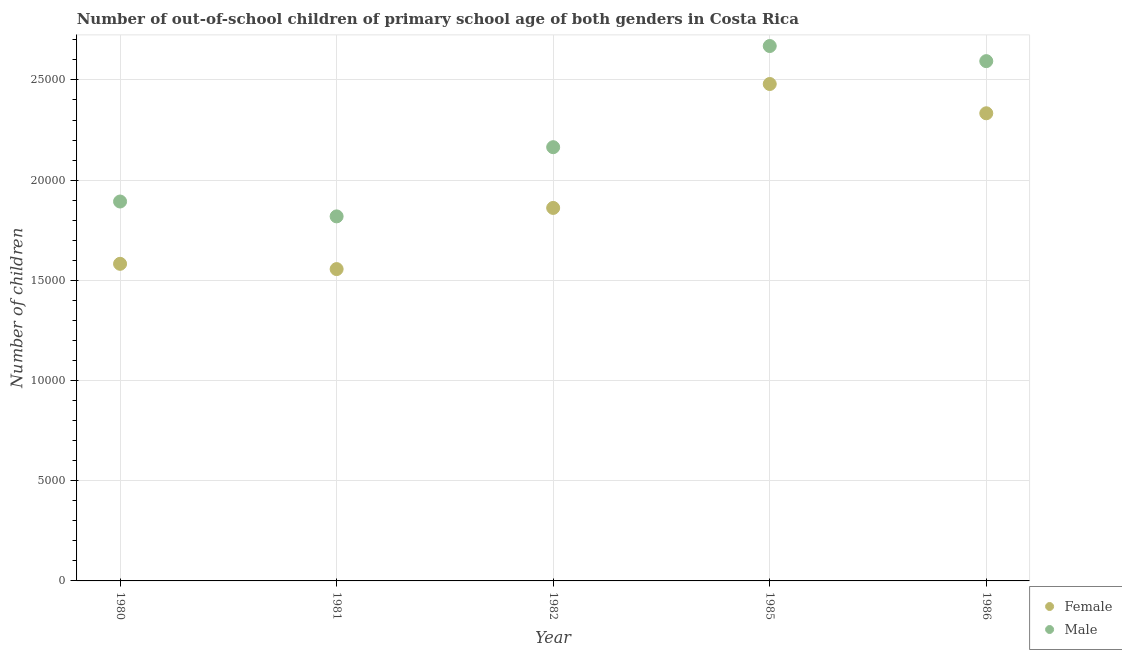How many different coloured dotlines are there?
Give a very brief answer. 2. What is the number of female out-of-school students in 1980?
Offer a terse response. 1.58e+04. Across all years, what is the maximum number of female out-of-school students?
Offer a very short reply. 2.48e+04. Across all years, what is the minimum number of male out-of-school students?
Your answer should be compact. 1.82e+04. What is the total number of male out-of-school students in the graph?
Make the answer very short. 1.11e+05. What is the difference between the number of male out-of-school students in 1980 and that in 1982?
Your answer should be compact. -2711. What is the difference between the number of male out-of-school students in 1982 and the number of female out-of-school students in 1980?
Keep it short and to the point. 5820. What is the average number of female out-of-school students per year?
Offer a terse response. 1.96e+04. In the year 1980, what is the difference between the number of male out-of-school students and number of female out-of-school students?
Offer a terse response. 3109. In how many years, is the number of female out-of-school students greater than 15000?
Provide a succinct answer. 5. What is the ratio of the number of female out-of-school students in 1980 to that in 1981?
Ensure brevity in your answer.  1.02. What is the difference between the highest and the second highest number of female out-of-school students?
Give a very brief answer. 1461. What is the difference between the highest and the lowest number of male out-of-school students?
Your answer should be compact. 8501. In how many years, is the number of male out-of-school students greater than the average number of male out-of-school students taken over all years?
Give a very brief answer. 2. Does the number of female out-of-school students monotonically increase over the years?
Provide a succinct answer. No. How many dotlines are there?
Make the answer very short. 2. How many years are there in the graph?
Provide a succinct answer. 5. Does the graph contain any zero values?
Give a very brief answer. No. Does the graph contain grids?
Give a very brief answer. Yes. Where does the legend appear in the graph?
Your answer should be compact. Bottom right. How many legend labels are there?
Offer a very short reply. 2. What is the title of the graph?
Your answer should be compact. Number of out-of-school children of primary school age of both genders in Costa Rica. Does "Food and tobacco" appear as one of the legend labels in the graph?
Give a very brief answer. No. What is the label or title of the X-axis?
Offer a very short reply. Year. What is the label or title of the Y-axis?
Your answer should be very brief. Number of children. What is the Number of children of Female in 1980?
Offer a very short reply. 1.58e+04. What is the Number of children of Male in 1980?
Your answer should be very brief. 1.89e+04. What is the Number of children of Female in 1981?
Offer a very short reply. 1.56e+04. What is the Number of children of Male in 1981?
Give a very brief answer. 1.82e+04. What is the Number of children of Female in 1982?
Make the answer very short. 1.86e+04. What is the Number of children in Male in 1982?
Your response must be concise. 2.16e+04. What is the Number of children in Female in 1985?
Provide a short and direct response. 2.48e+04. What is the Number of children of Male in 1985?
Your answer should be compact. 2.67e+04. What is the Number of children of Female in 1986?
Ensure brevity in your answer.  2.33e+04. What is the Number of children in Male in 1986?
Ensure brevity in your answer.  2.59e+04. Across all years, what is the maximum Number of children of Female?
Your answer should be compact. 2.48e+04. Across all years, what is the maximum Number of children of Male?
Your answer should be very brief. 2.67e+04. Across all years, what is the minimum Number of children of Female?
Make the answer very short. 1.56e+04. Across all years, what is the minimum Number of children in Male?
Keep it short and to the point. 1.82e+04. What is the total Number of children in Female in the graph?
Offer a terse response. 9.81e+04. What is the total Number of children of Male in the graph?
Provide a succinct answer. 1.11e+05. What is the difference between the Number of children in Female in 1980 and that in 1981?
Offer a very short reply. 263. What is the difference between the Number of children in Male in 1980 and that in 1981?
Give a very brief answer. 742. What is the difference between the Number of children of Female in 1980 and that in 1982?
Keep it short and to the point. -2789. What is the difference between the Number of children in Male in 1980 and that in 1982?
Your answer should be compact. -2711. What is the difference between the Number of children of Female in 1980 and that in 1985?
Your response must be concise. -8973. What is the difference between the Number of children in Male in 1980 and that in 1985?
Provide a short and direct response. -7759. What is the difference between the Number of children in Female in 1980 and that in 1986?
Keep it short and to the point. -7512. What is the difference between the Number of children in Male in 1980 and that in 1986?
Keep it short and to the point. -7005. What is the difference between the Number of children in Female in 1981 and that in 1982?
Give a very brief answer. -3052. What is the difference between the Number of children of Male in 1981 and that in 1982?
Offer a very short reply. -3453. What is the difference between the Number of children of Female in 1981 and that in 1985?
Your answer should be very brief. -9236. What is the difference between the Number of children in Male in 1981 and that in 1985?
Keep it short and to the point. -8501. What is the difference between the Number of children of Female in 1981 and that in 1986?
Ensure brevity in your answer.  -7775. What is the difference between the Number of children of Male in 1981 and that in 1986?
Your answer should be compact. -7747. What is the difference between the Number of children of Female in 1982 and that in 1985?
Offer a very short reply. -6184. What is the difference between the Number of children in Male in 1982 and that in 1985?
Provide a succinct answer. -5048. What is the difference between the Number of children in Female in 1982 and that in 1986?
Provide a short and direct response. -4723. What is the difference between the Number of children in Male in 1982 and that in 1986?
Ensure brevity in your answer.  -4294. What is the difference between the Number of children in Female in 1985 and that in 1986?
Keep it short and to the point. 1461. What is the difference between the Number of children of Male in 1985 and that in 1986?
Provide a succinct answer. 754. What is the difference between the Number of children of Female in 1980 and the Number of children of Male in 1981?
Provide a short and direct response. -2367. What is the difference between the Number of children in Female in 1980 and the Number of children in Male in 1982?
Your answer should be very brief. -5820. What is the difference between the Number of children in Female in 1980 and the Number of children in Male in 1985?
Offer a very short reply. -1.09e+04. What is the difference between the Number of children of Female in 1980 and the Number of children of Male in 1986?
Offer a terse response. -1.01e+04. What is the difference between the Number of children in Female in 1981 and the Number of children in Male in 1982?
Keep it short and to the point. -6083. What is the difference between the Number of children of Female in 1981 and the Number of children of Male in 1985?
Keep it short and to the point. -1.11e+04. What is the difference between the Number of children of Female in 1981 and the Number of children of Male in 1986?
Your answer should be very brief. -1.04e+04. What is the difference between the Number of children in Female in 1982 and the Number of children in Male in 1985?
Provide a short and direct response. -8079. What is the difference between the Number of children in Female in 1982 and the Number of children in Male in 1986?
Offer a terse response. -7325. What is the difference between the Number of children in Female in 1985 and the Number of children in Male in 1986?
Your answer should be very brief. -1141. What is the average Number of children of Female per year?
Offer a terse response. 1.96e+04. What is the average Number of children of Male per year?
Your answer should be compact. 2.23e+04. In the year 1980, what is the difference between the Number of children of Female and Number of children of Male?
Keep it short and to the point. -3109. In the year 1981, what is the difference between the Number of children of Female and Number of children of Male?
Make the answer very short. -2630. In the year 1982, what is the difference between the Number of children in Female and Number of children in Male?
Your answer should be very brief. -3031. In the year 1985, what is the difference between the Number of children of Female and Number of children of Male?
Offer a very short reply. -1895. In the year 1986, what is the difference between the Number of children of Female and Number of children of Male?
Your answer should be very brief. -2602. What is the ratio of the Number of children of Female in 1980 to that in 1981?
Your answer should be compact. 1.02. What is the ratio of the Number of children in Male in 1980 to that in 1981?
Your answer should be very brief. 1.04. What is the ratio of the Number of children in Female in 1980 to that in 1982?
Offer a terse response. 0.85. What is the ratio of the Number of children in Male in 1980 to that in 1982?
Offer a terse response. 0.87. What is the ratio of the Number of children in Female in 1980 to that in 1985?
Ensure brevity in your answer.  0.64. What is the ratio of the Number of children of Male in 1980 to that in 1985?
Your answer should be compact. 0.71. What is the ratio of the Number of children in Female in 1980 to that in 1986?
Offer a very short reply. 0.68. What is the ratio of the Number of children in Male in 1980 to that in 1986?
Ensure brevity in your answer.  0.73. What is the ratio of the Number of children in Female in 1981 to that in 1982?
Give a very brief answer. 0.84. What is the ratio of the Number of children of Male in 1981 to that in 1982?
Your answer should be very brief. 0.84. What is the ratio of the Number of children of Female in 1981 to that in 1985?
Provide a succinct answer. 0.63. What is the ratio of the Number of children of Male in 1981 to that in 1985?
Your response must be concise. 0.68. What is the ratio of the Number of children of Female in 1981 to that in 1986?
Provide a short and direct response. 0.67. What is the ratio of the Number of children of Male in 1981 to that in 1986?
Offer a terse response. 0.7. What is the ratio of the Number of children of Female in 1982 to that in 1985?
Provide a succinct answer. 0.75. What is the ratio of the Number of children of Male in 1982 to that in 1985?
Provide a succinct answer. 0.81. What is the ratio of the Number of children in Female in 1982 to that in 1986?
Keep it short and to the point. 0.8. What is the ratio of the Number of children in Male in 1982 to that in 1986?
Give a very brief answer. 0.83. What is the ratio of the Number of children in Female in 1985 to that in 1986?
Offer a very short reply. 1.06. What is the ratio of the Number of children in Male in 1985 to that in 1986?
Ensure brevity in your answer.  1.03. What is the difference between the highest and the second highest Number of children in Female?
Provide a succinct answer. 1461. What is the difference between the highest and the second highest Number of children of Male?
Your response must be concise. 754. What is the difference between the highest and the lowest Number of children of Female?
Your answer should be very brief. 9236. What is the difference between the highest and the lowest Number of children of Male?
Give a very brief answer. 8501. 